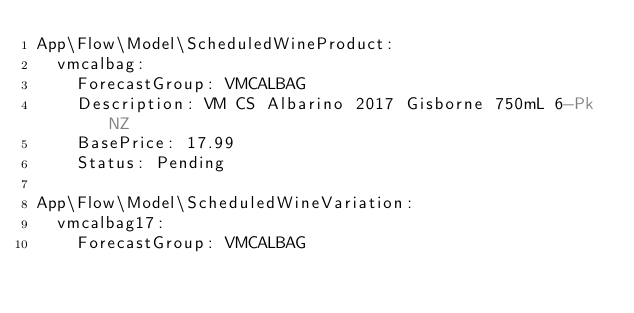Convert code to text. <code><loc_0><loc_0><loc_500><loc_500><_YAML_>App\Flow\Model\ScheduledWineProduct:
  vmcalbag:
    ForecastGroup: VMCALBAG
    Description: VM CS Albarino 2017 Gisborne 750mL 6-Pk NZ
    BasePrice: 17.99
    Status: Pending

App\Flow\Model\ScheduledWineVariation:
  vmcalbag17:
    ForecastGroup: VMCALBAG</code> 